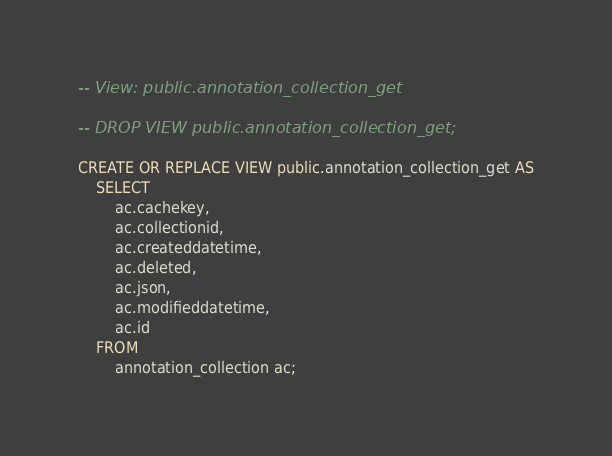<code> <loc_0><loc_0><loc_500><loc_500><_SQL_>-- View: public.annotation_collection_get

-- DROP VIEW public.annotation_collection_get;

CREATE OR REPLACE VIEW public.annotation_collection_get AS
    SELECT
        ac.cachekey,
        ac.collectionid,
        ac.createddatetime,
        ac.deleted,
        ac.json,
        ac.modifieddatetime,
        ac.id
    FROM
        annotation_collection ac;
</code> 